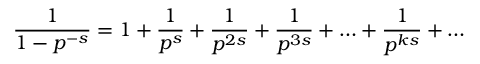<formula> <loc_0><loc_0><loc_500><loc_500>{ \frac { 1 } { 1 - p ^ { - s } } } = 1 + { \frac { 1 } { p ^ { s } } } + { \frac { 1 } { p ^ { 2 s } } } + { \frac { 1 } { p ^ { 3 s } } } + \dots + { \frac { 1 } { p ^ { k s } } } + \dots</formula> 